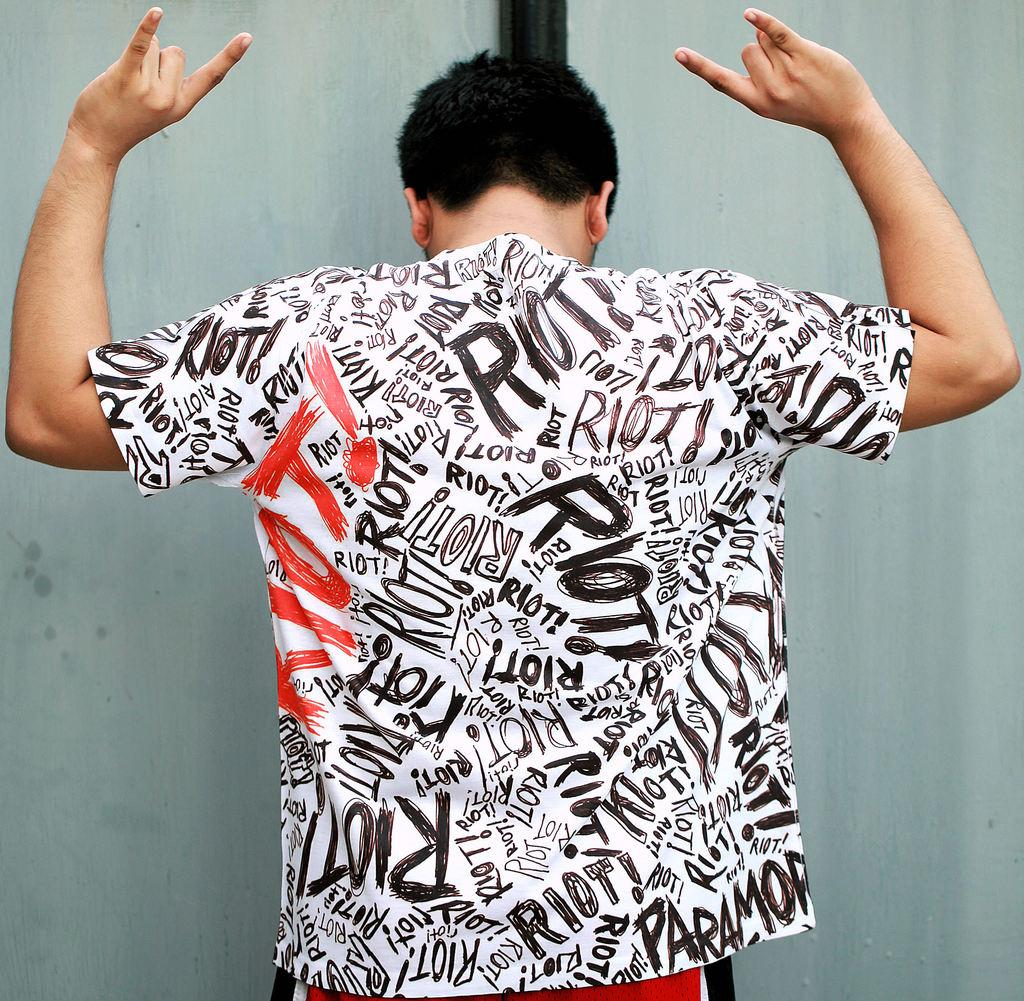<image>
Write a terse but informative summary of the picture. the man is wearing a shirt full of the word Riot 